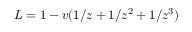Convert formula to latex. <formula><loc_0><loc_0><loc_500><loc_500>L = 1 - v ( 1 / z + 1 / z ^ { 2 } + 1 / z ^ { 3 } )</formula> 